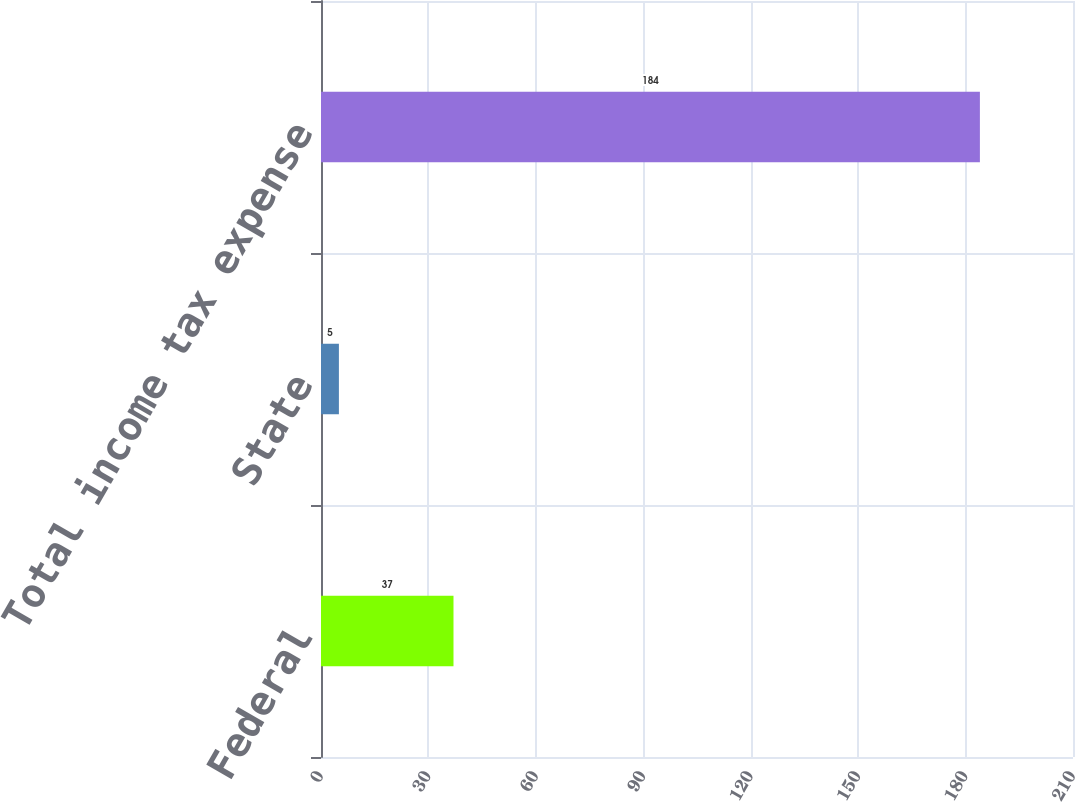<chart> <loc_0><loc_0><loc_500><loc_500><bar_chart><fcel>Federal<fcel>State<fcel>Total income tax expense<nl><fcel>37<fcel>5<fcel>184<nl></chart> 